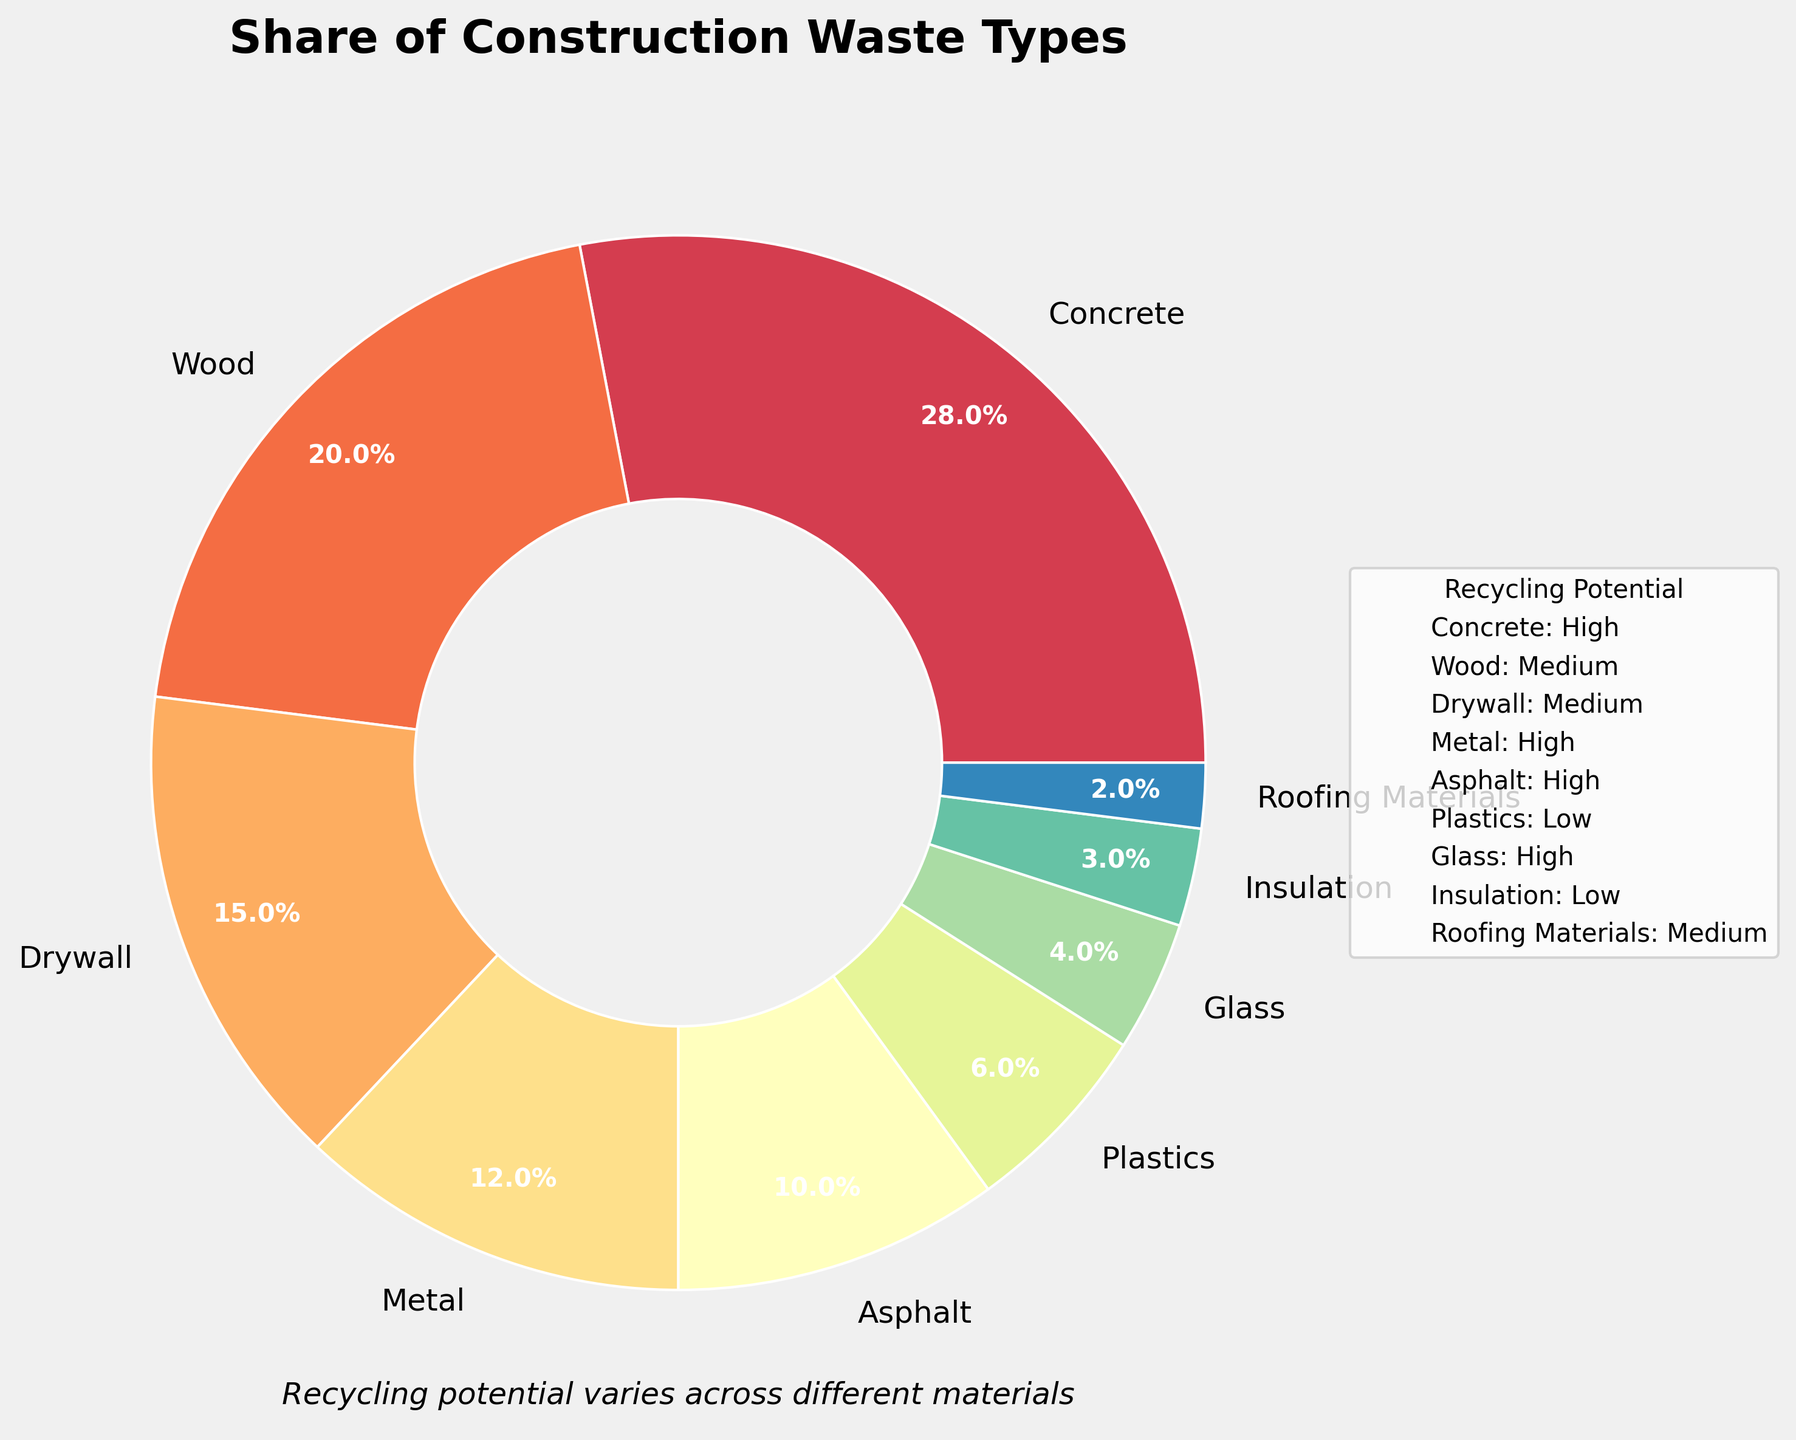Which material has the highest share in construction waste? The material with the highest percentage in the pie chart is the one with the highest share. Concrete has a share of 28%, which is the highest.
Answer: Concrete Which three materials have the highest recycling potential and what are their percentages? The materials with the recycling potential labeled as "High" are the ones we are interested in. These materials are Concrete (28%), Metal (12%), and Glass (4%).
Answer: Concrete (28%), Metal (12%), and Glass (4%) What is the total percentage share of materials with low recycling potential? Sum the percentages of the materials labeled with "Low" recycling potential. These materials are Plastics (6%) and Insulation (3%) which, when added together, give 6% + 3% = 9%.
Answer: 9% How does the percentage of wood compare to the percentage of metal? Check the percentages of both Wood and Metal from the pie chart. Wood has a share of 20%, whereas Metal has a share of 12%.
Answer: Wood is higher Which material has the smallest share in construction waste and what is its recycling potential? The material with the smallest percentage in the pie chart will have the smallest share. Roofing Materials have a share of 2%, which is the smallest, and its recycling potential is Medium.
Answer: Roofing Materials with Medium recycling potential Among the materials with medium recycling potential, which one has the highest share? First identify materials with a "Medium" recycling potential: Wood (20%), Drywall (15%), and Roofing Materials (2%). Then compare their percentages, where Wood (20%) has the highest share.
Answer: Wood What is the combined share of Concrete and Asphalt in construction waste? Sum the percentages of Concrete (28%) and Asphalt (10%). The combined share is 28% + 10% = 38%.
Answer: 38% Which material with high recycling potential has the smallest percentage share? Among the materials labeled with "High" recycling potential, identify the one with the smallest percentage. Glass has a share of 4%, which is the smallest among the high recycling potential materials.
Answer: Glass What is the difference in percentage share between Drywall and Asphalt? Subtract the percentage of Asphalt (10%) from the percentage of Drywall (15%). The difference is 15% - 10% = 5%.
Answer: 5% What is the average percentage share of materials with medium recycling potential? First, sum the percentages of all materials with medium recycling potential: Wood (20%), Drywall (15%), and Roofing Materials (2%). The sum is 20% + 15% + 2% = 37%. There are 3 materials, so the average is 37% / 3 ≈ 12.33%.
Answer: 12.33% 